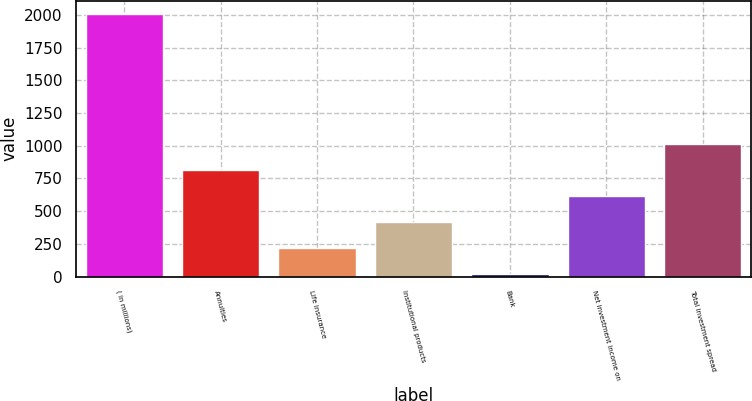Convert chart. <chart><loc_0><loc_0><loc_500><loc_500><bar_chart><fcel>( in millions)<fcel>Annuities<fcel>Life insurance<fcel>Institutional products<fcel>Bank<fcel>Net investment income on<fcel>Total investment spread<nl><fcel>2008<fcel>816.4<fcel>220.6<fcel>419.2<fcel>22<fcel>617.8<fcel>1015<nl></chart> 